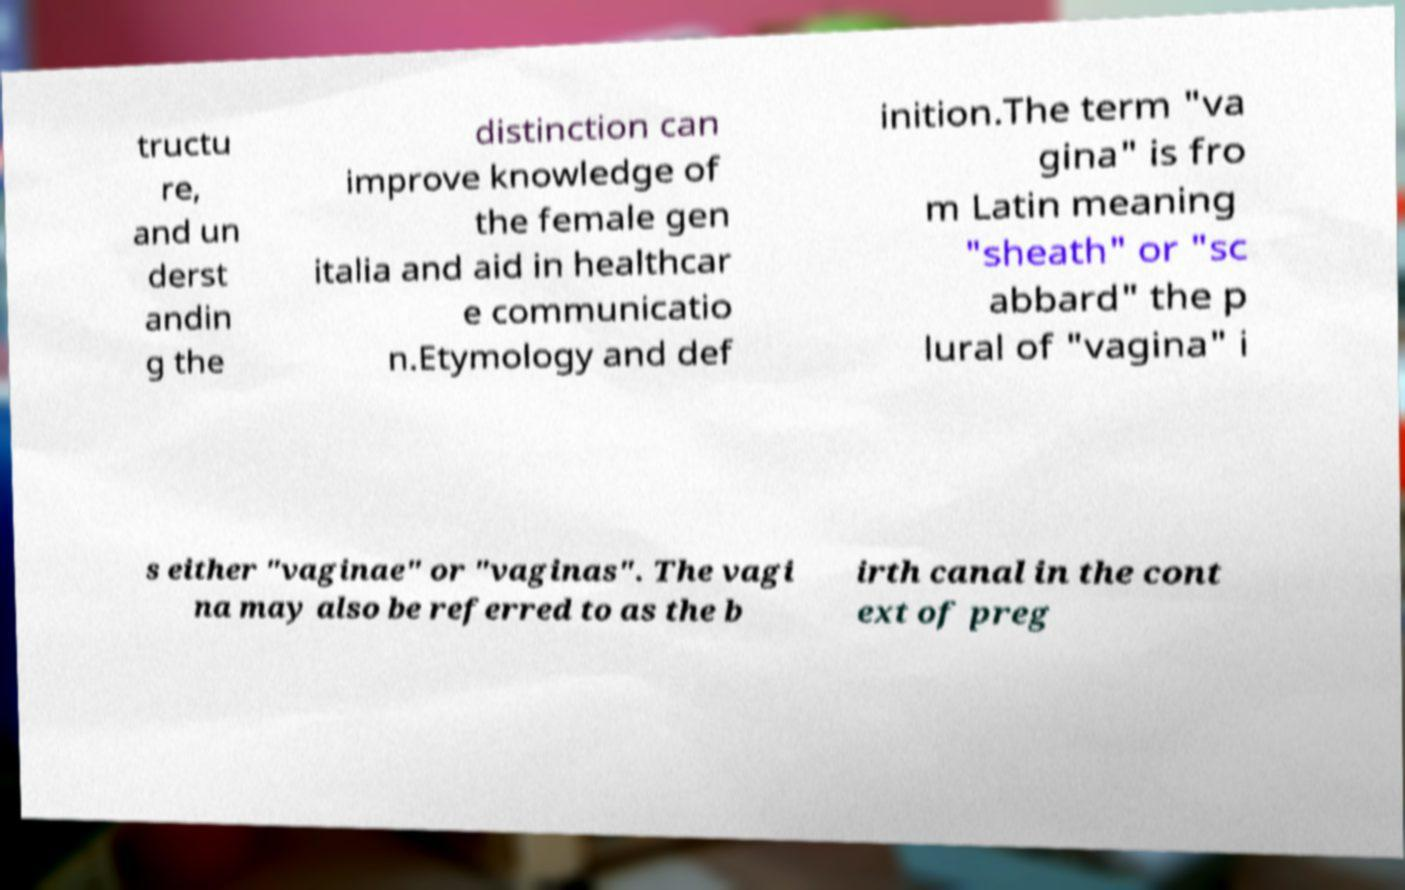Could you assist in decoding the text presented in this image and type it out clearly? tructu re, and un derst andin g the distinction can improve knowledge of the female gen italia and aid in healthcar e communicatio n.Etymology and def inition.The term "va gina" is fro m Latin meaning "sheath" or "sc abbard" the p lural of "vagina" i s either "vaginae" or "vaginas". The vagi na may also be referred to as the b irth canal in the cont ext of preg 